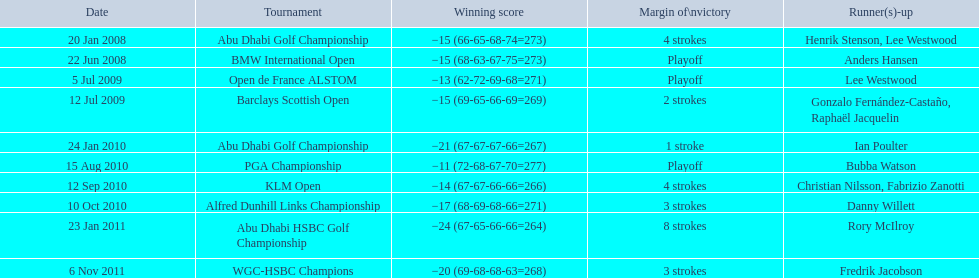How many additional strokes occurred in the klm open compared to the barclays scottish open? 2 strokes. 